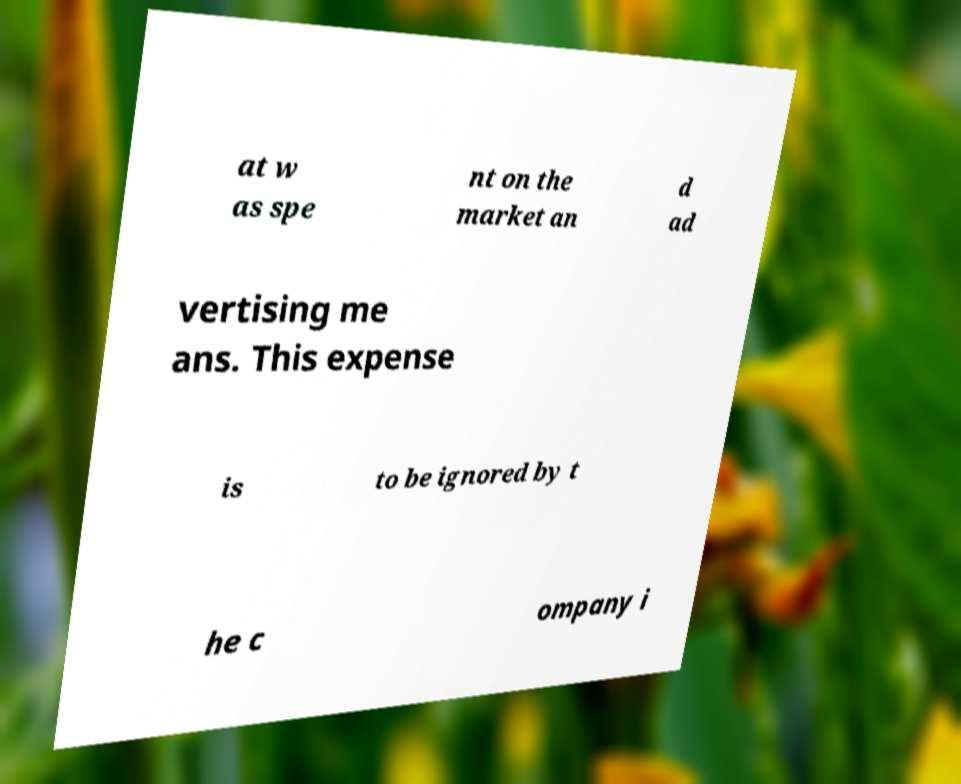For documentation purposes, I need the text within this image transcribed. Could you provide that? at w as spe nt on the market an d ad vertising me ans. This expense is to be ignored by t he c ompany i 